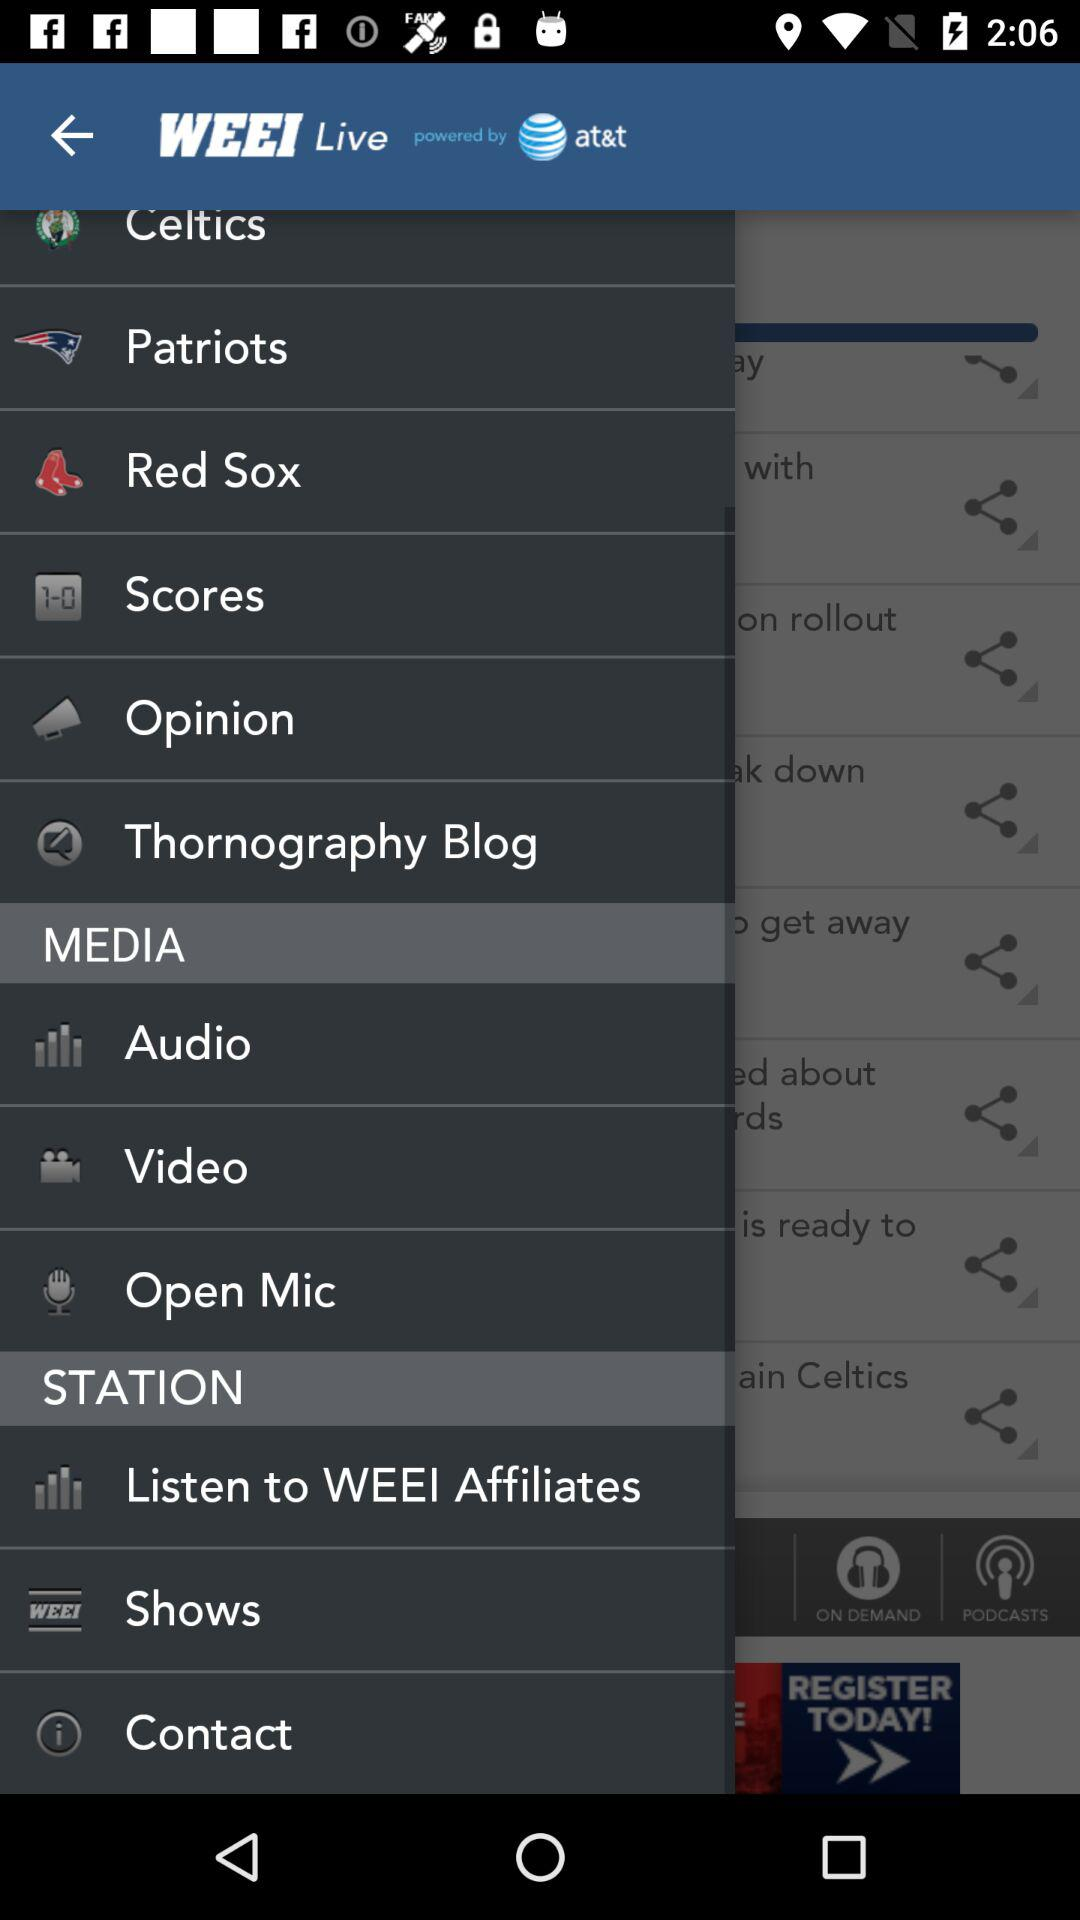What is the name of the application? The name of the application is WEEI. 